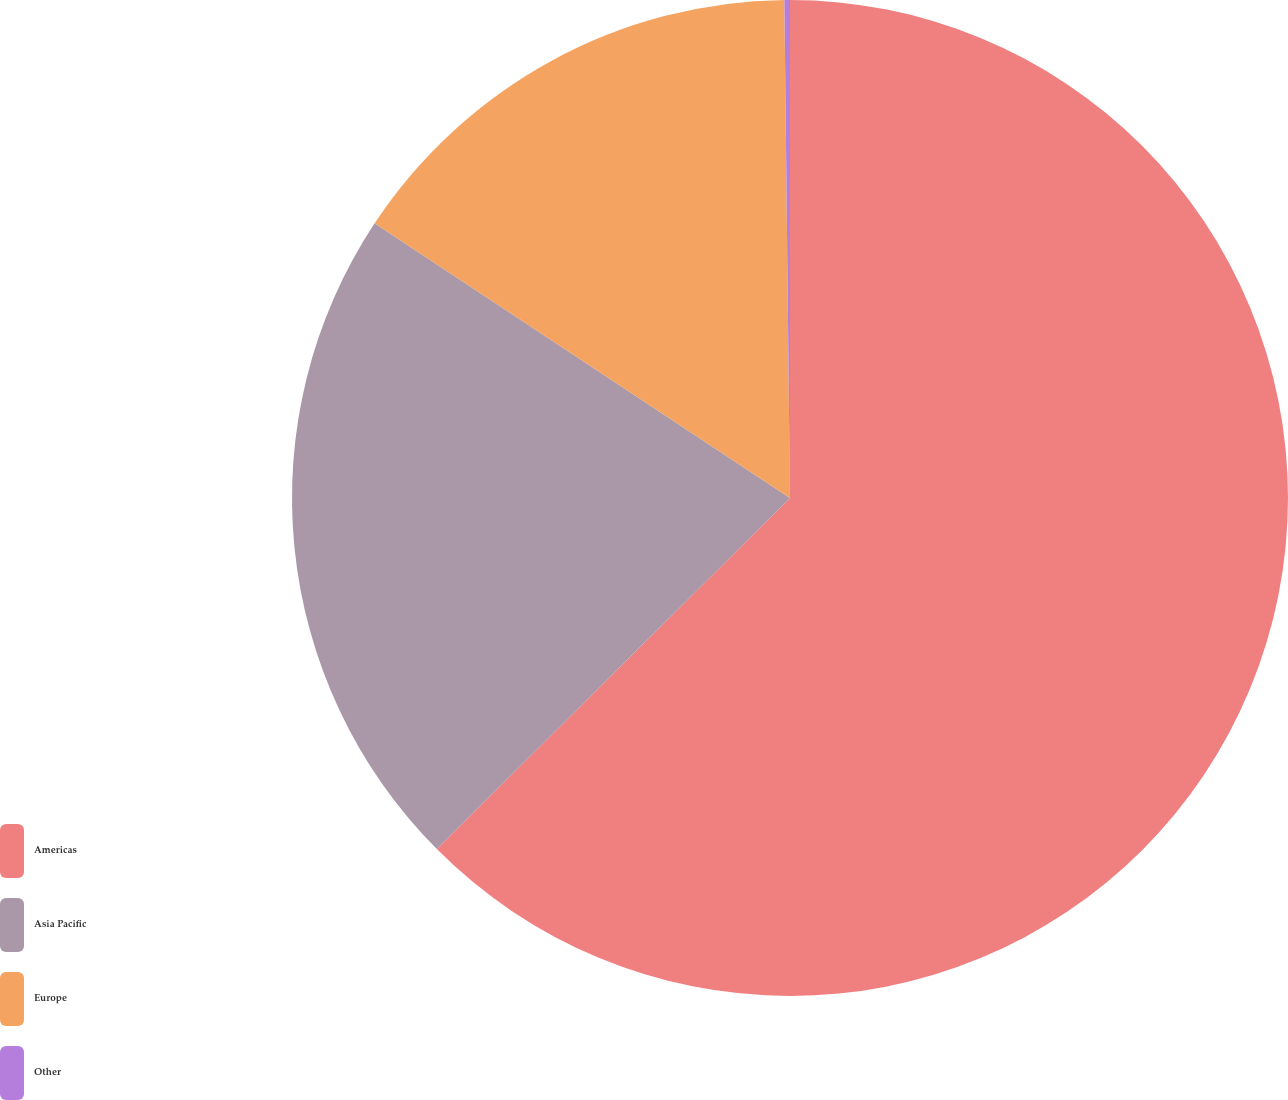Convert chart. <chart><loc_0><loc_0><loc_500><loc_500><pie_chart><fcel>Americas<fcel>Asia Pacific<fcel>Europe<fcel>Other<nl><fcel>62.54%<fcel>21.75%<fcel>15.52%<fcel>0.18%<nl></chart> 